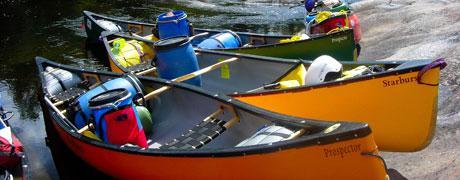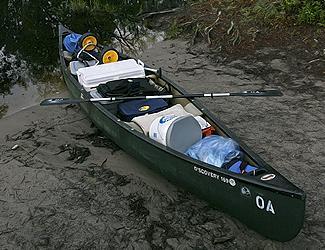The first image is the image on the left, the second image is the image on the right. Given the left and right images, does the statement "All boats are pictured in an area with water and full of gear, but no boats have a person inside." hold true? Answer yes or no. Yes. The first image is the image on the left, the second image is the image on the right. For the images displayed, is the sentence "The right image includes one red canoe." factually correct? Answer yes or no. No. 